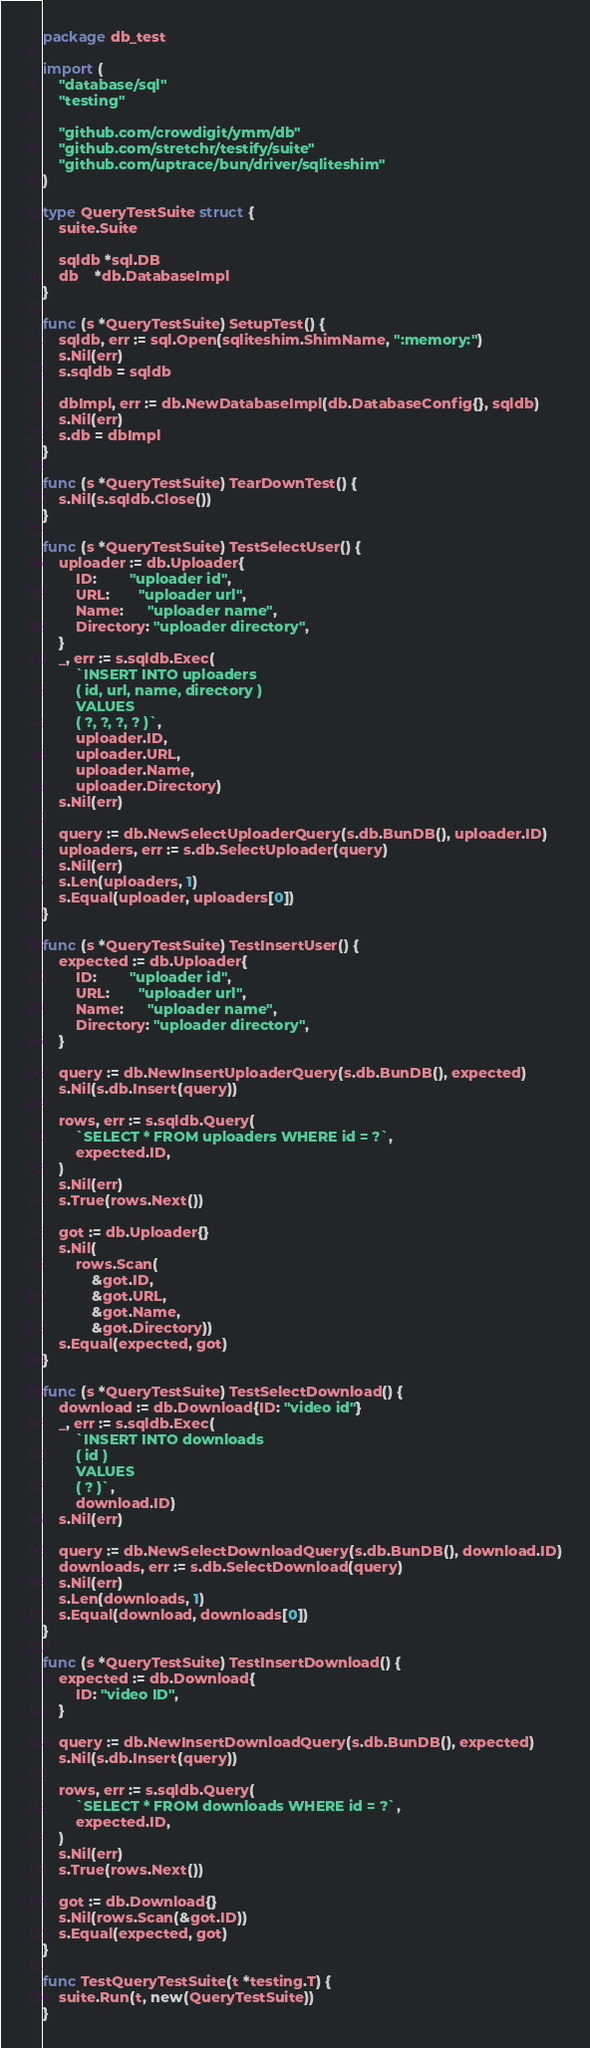Convert code to text. <code><loc_0><loc_0><loc_500><loc_500><_Go_>package db_test

import (
	"database/sql"
	"testing"

	"github.com/crowdigit/ymm/db"
	"github.com/stretchr/testify/suite"
	"github.com/uptrace/bun/driver/sqliteshim"
)

type QueryTestSuite struct {
	suite.Suite

	sqldb *sql.DB
	db    *db.DatabaseImpl
}

func (s *QueryTestSuite) SetupTest() {
	sqldb, err := sql.Open(sqliteshim.ShimName, ":memory:")
	s.Nil(err)
	s.sqldb = sqldb

	dbImpl, err := db.NewDatabaseImpl(db.DatabaseConfig{}, sqldb)
	s.Nil(err)
	s.db = dbImpl
}

func (s *QueryTestSuite) TearDownTest() {
	s.Nil(s.sqldb.Close())
}

func (s *QueryTestSuite) TestSelectUser() {
	uploader := db.Uploader{
		ID:        "uploader id",
		URL:       "uploader url",
		Name:      "uploader name",
		Directory: "uploader directory",
	}
	_, err := s.sqldb.Exec(
		`INSERT INTO uploaders
		( id, url, name, directory )
		VALUES
		( ?, ?, ?, ? )`,
		uploader.ID,
		uploader.URL,
		uploader.Name,
		uploader.Directory)
	s.Nil(err)

	query := db.NewSelectUploaderQuery(s.db.BunDB(), uploader.ID)
	uploaders, err := s.db.SelectUploader(query)
	s.Nil(err)
	s.Len(uploaders, 1)
	s.Equal(uploader, uploaders[0])
}

func (s *QueryTestSuite) TestInsertUser() {
	expected := db.Uploader{
		ID:        "uploader id",
		URL:       "uploader url",
		Name:      "uploader name",
		Directory: "uploader directory",
	}

	query := db.NewInsertUploaderQuery(s.db.BunDB(), expected)
	s.Nil(s.db.Insert(query))

	rows, err := s.sqldb.Query(
		`SELECT * FROM uploaders WHERE id = ?`,
		expected.ID,
	)
	s.Nil(err)
	s.True(rows.Next())

	got := db.Uploader{}
	s.Nil(
		rows.Scan(
			&got.ID,
			&got.URL,
			&got.Name,
			&got.Directory))
	s.Equal(expected, got)
}

func (s *QueryTestSuite) TestSelectDownload() {
	download := db.Download{ID: "video id"}
	_, err := s.sqldb.Exec(
		`INSERT INTO downloads
		( id )
		VALUES
		( ? )`,
		download.ID)
	s.Nil(err)

	query := db.NewSelectDownloadQuery(s.db.BunDB(), download.ID)
	downloads, err := s.db.SelectDownload(query)
	s.Nil(err)
	s.Len(downloads, 1)
	s.Equal(download, downloads[0])
}

func (s *QueryTestSuite) TestInsertDownload() {
	expected := db.Download{
		ID: "video ID",
	}

	query := db.NewInsertDownloadQuery(s.db.BunDB(), expected)
	s.Nil(s.db.Insert(query))

	rows, err := s.sqldb.Query(
		`SELECT * FROM downloads WHERE id = ?`,
		expected.ID,
	)
	s.Nil(err)
	s.True(rows.Next())

	got := db.Download{}
	s.Nil(rows.Scan(&got.ID))
	s.Equal(expected, got)
}

func TestQueryTestSuite(t *testing.T) {
	suite.Run(t, new(QueryTestSuite))
}
</code> 